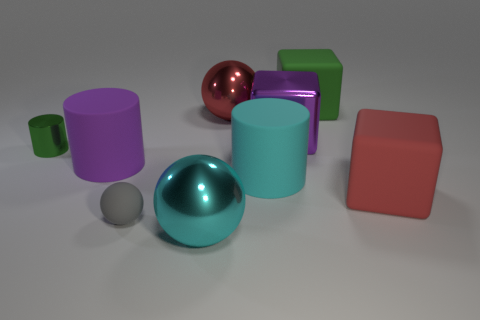Which object in the image appears to be the most reflective? The object that appears most reflective is the pinkish-red metallic sphere. Its mirror-like surface clearly reflects the environment around it, including other geometric shapes nearby. What might be the light source in this image, based on the reflections and shadows? Judging by the direction of the shadows and the highlights on the objects, it seems there is a diffuse overhead light source illuminating the scene, possibly mimicking ambient daylight in an indoor setting. 